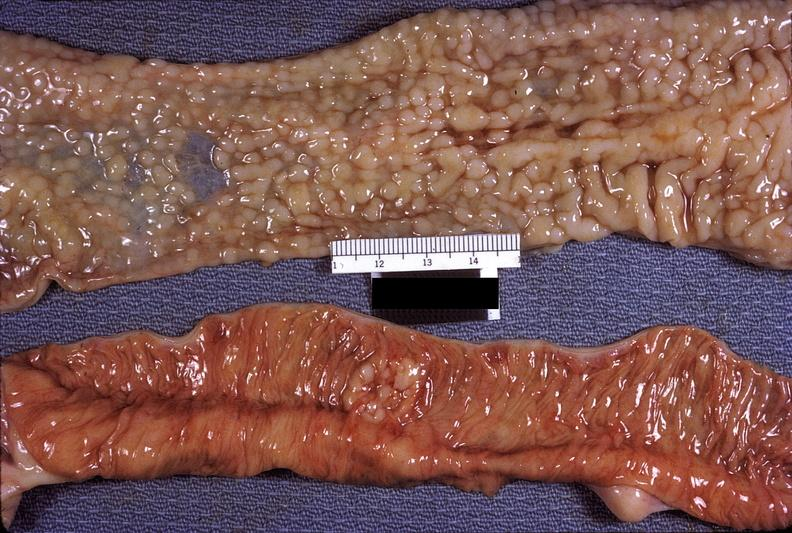what does this image show?
Answer the question using a single word or phrase. Small intestine 